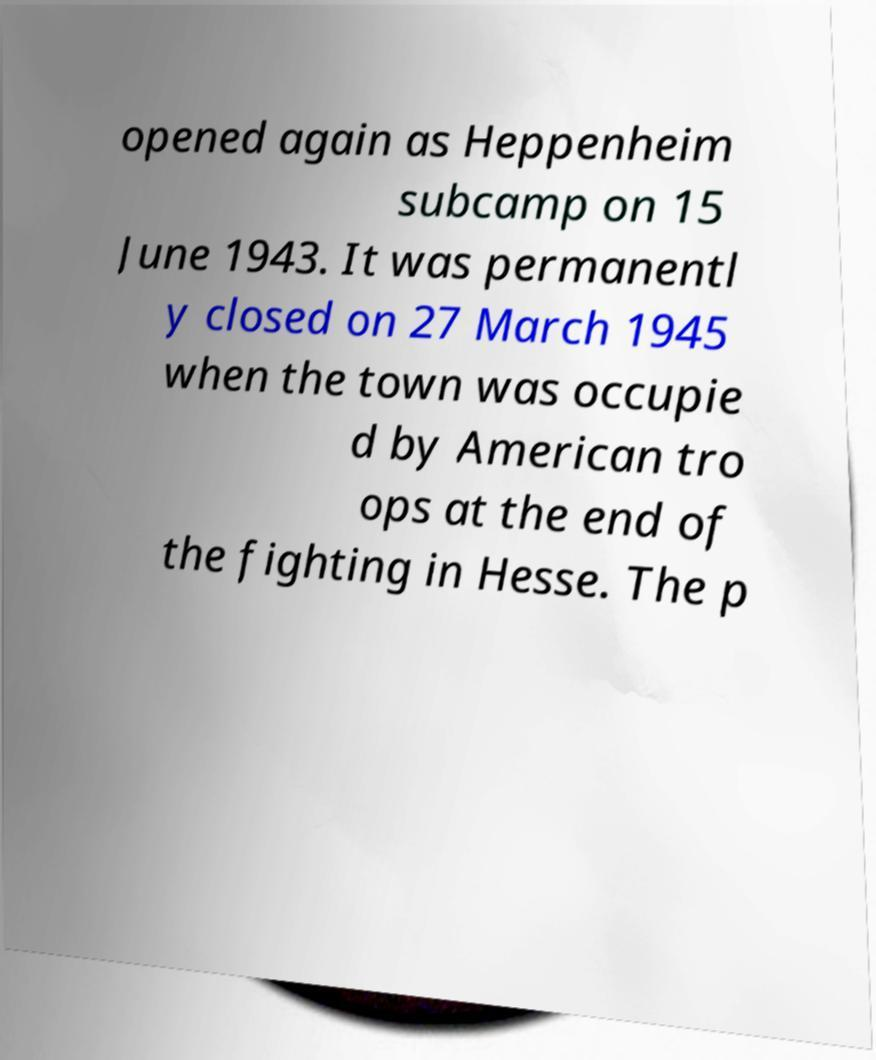Please read and relay the text visible in this image. What does it say? opened again as Heppenheim subcamp on 15 June 1943. It was permanentl y closed on 27 March 1945 when the town was occupie d by American tro ops at the end of the fighting in Hesse. The p 